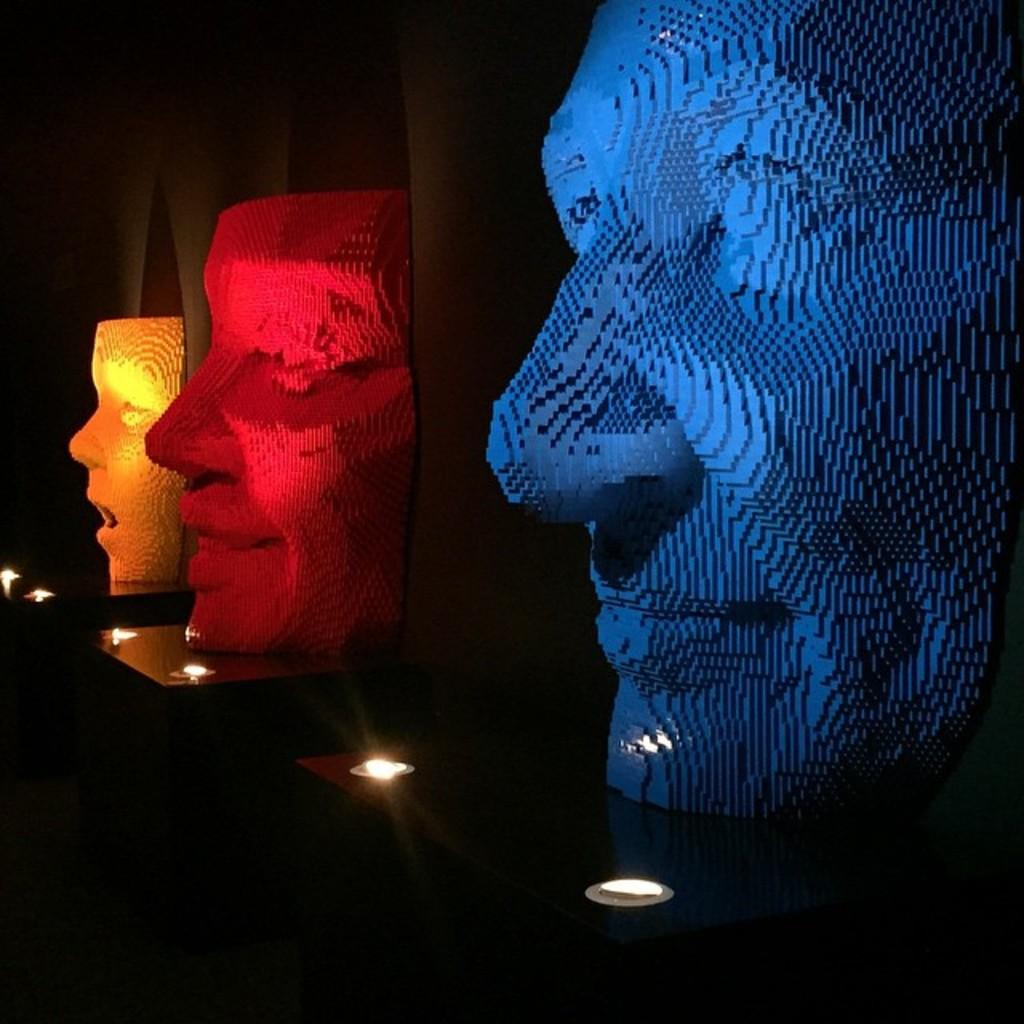What type of objects are depicted in the image? There are colorful statues of faces in the image. How do the statues differ from one another? The statues have different expressions. What is present in front of each sculpture? There are two lights in front of each sculpture. What type of scarf is draped around the chin of the statue on the left? There is no scarf present around the chin of any statue in the image. 